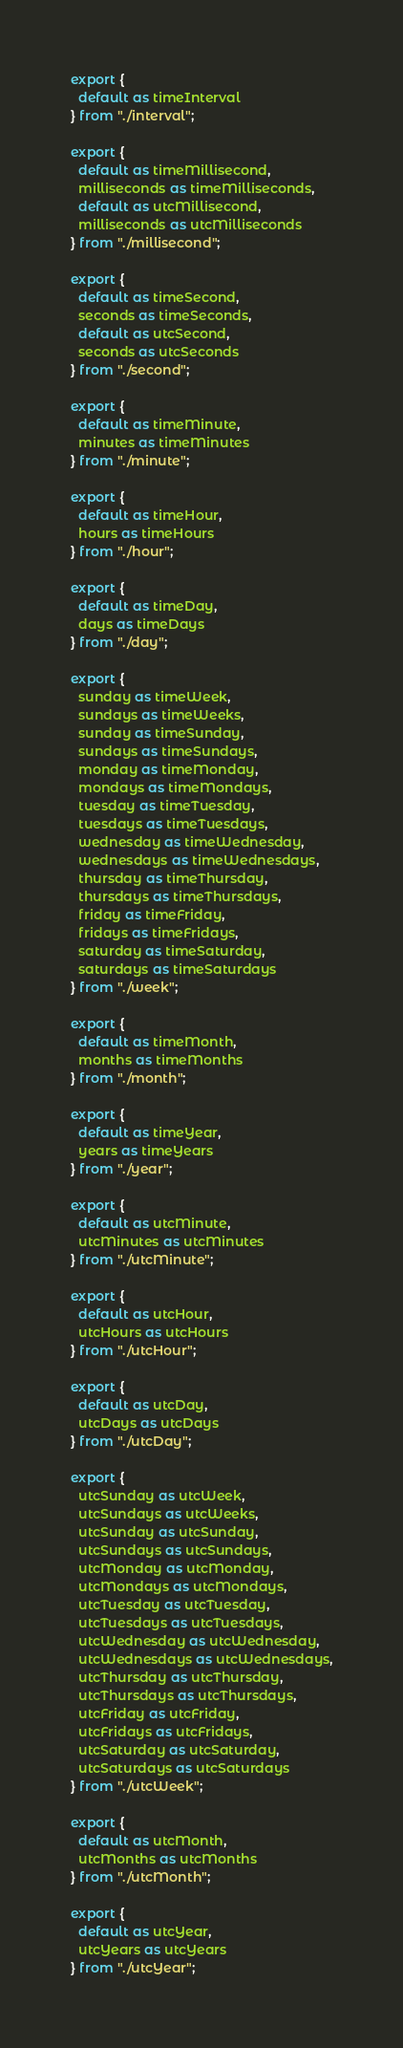<code> <loc_0><loc_0><loc_500><loc_500><_JavaScript_>export {
  default as timeInterval
} from "./interval";

export {
  default as timeMillisecond,
  milliseconds as timeMilliseconds,
  default as utcMillisecond,
  milliseconds as utcMilliseconds
} from "./millisecond";

export {
  default as timeSecond,
  seconds as timeSeconds,
  default as utcSecond,
  seconds as utcSeconds
} from "./second";

export {
  default as timeMinute,
  minutes as timeMinutes
} from "./minute";

export {
  default as timeHour,
  hours as timeHours
} from "./hour";

export {
  default as timeDay,
  days as timeDays
} from "./day";

export {
  sunday as timeWeek,
  sundays as timeWeeks,
  sunday as timeSunday,
  sundays as timeSundays,
  monday as timeMonday,
  mondays as timeMondays,
  tuesday as timeTuesday,
  tuesdays as timeTuesdays,
  wednesday as timeWednesday,
  wednesdays as timeWednesdays,
  thursday as timeThursday,
  thursdays as timeThursdays,
  friday as timeFriday,
  fridays as timeFridays,
  saturday as timeSaturday,
  saturdays as timeSaturdays
} from "./week";

export {
  default as timeMonth,
  months as timeMonths
} from "./month";

export {
  default as timeYear,
  years as timeYears
} from "./year";

export {
  default as utcMinute,
  utcMinutes as utcMinutes
} from "./utcMinute";

export {
  default as utcHour,
  utcHours as utcHours
} from "./utcHour";

export {
  default as utcDay,
  utcDays as utcDays
} from "./utcDay";

export {
  utcSunday as utcWeek,
  utcSundays as utcWeeks,
  utcSunday as utcSunday,
  utcSundays as utcSundays,
  utcMonday as utcMonday,
  utcMondays as utcMondays,
  utcTuesday as utcTuesday,
  utcTuesdays as utcTuesdays,
  utcWednesday as utcWednesday,
  utcWednesdays as utcWednesdays,
  utcThursday as utcThursday,
  utcThursdays as utcThursdays,
  utcFriday as utcFriday,
  utcFridays as utcFridays,
  utcSaturday as utcSaturday,
  utcSaturdays as utcSaturdays
} from "./utcWeek";

export {
  default as utcMonth,
  utcMonths as utcMonths
} from "./utcMonth";

export {
  default as utcYear,
  utcYears as utcYears
} from "./utcYear";
</code> 